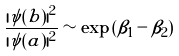<formula> <loc_0><loc_0><loc_500><loc_500>\frac { | \psi ( b ) | ^ { 2 } } { | \psi ( a ) | ^ { 2 } } \sim \exp \left ( \beta _ { 1 } - \beta _ { 2 } \right )</formula> 